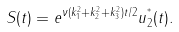<formula> <loc_0><loc_0><loc_500><loc_500>S ( t ) = e ^ { \nu ( k _ { 1 } ^ { 2 } + k _ { 2 } ^ { 2 } + k _ { 3 } ^ { 2 } ) t / 2 } u _ { 2 } ^ { ^ { * } } ( t ) .</formula> 